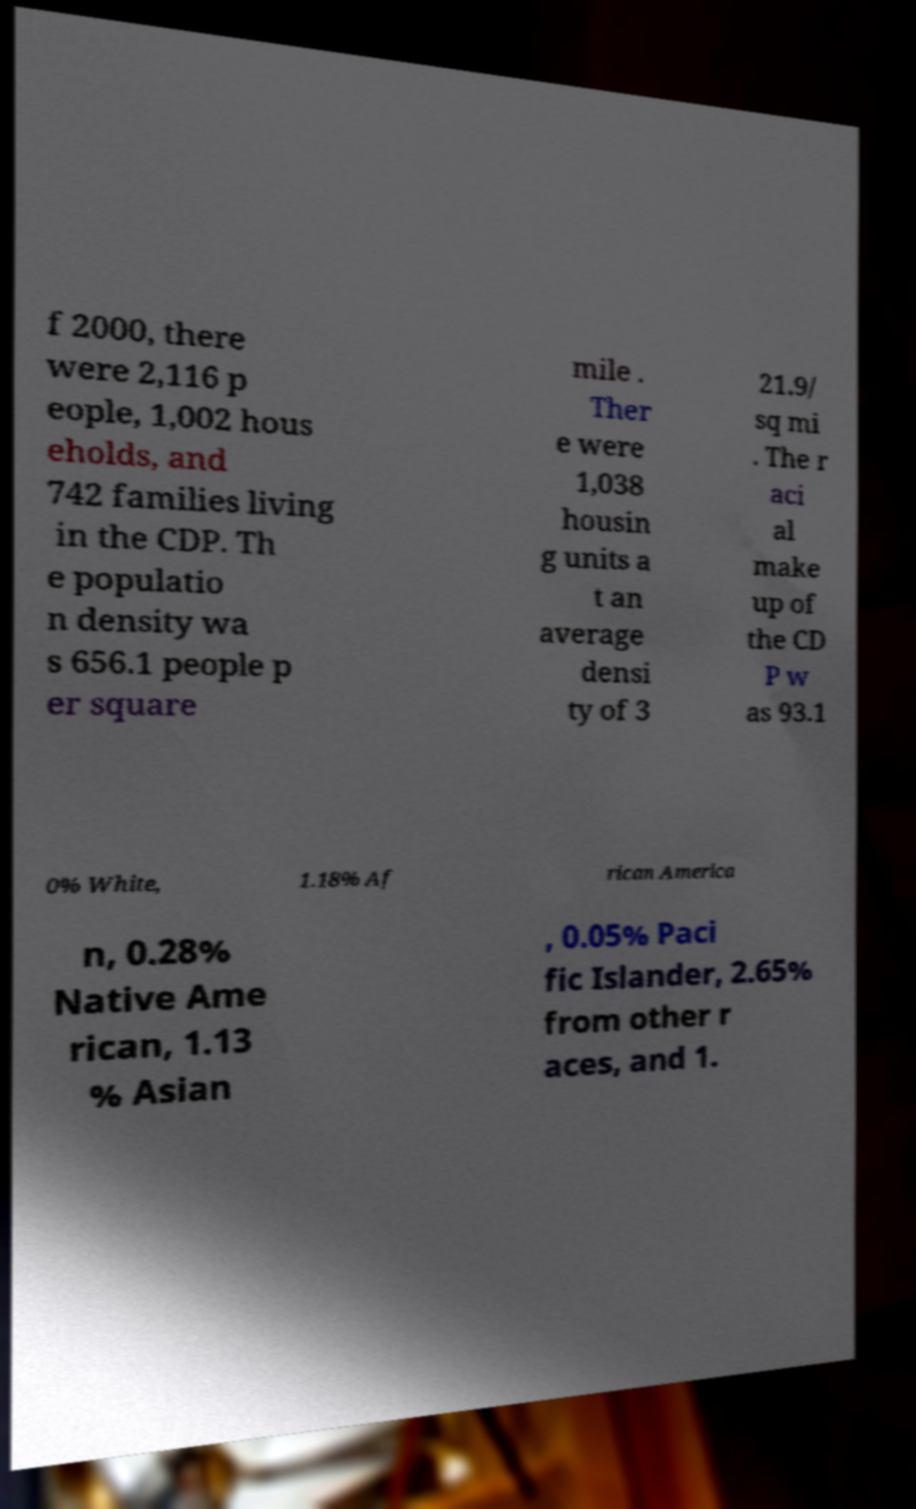I need the written content from this picture converted into text. Can you do that? f 2000, there were 2,116 p eople, 1,002 hous eholds, and 742 families living in the CDP. Th e populatio n density wa s 656.1 people p er square mile . Ther e were 1,038 housin g units a t an average densi ty of 3 21.9/ sq mi . The r aci al make up of the CD P w as 93.1 0% White, 1.18% Af rican America n, 0.28% Native Ame rican, 1.13 % Asian , 0.05% Paci fic Islander, 2.65% from other r aces, and 1. 